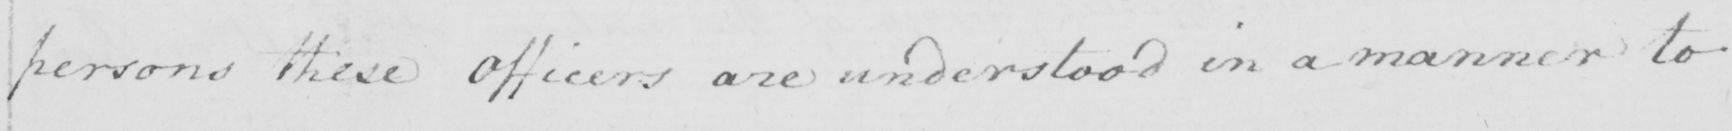Please transcribe the handwritten text in this image. persons these Officers are understood in a manner to 